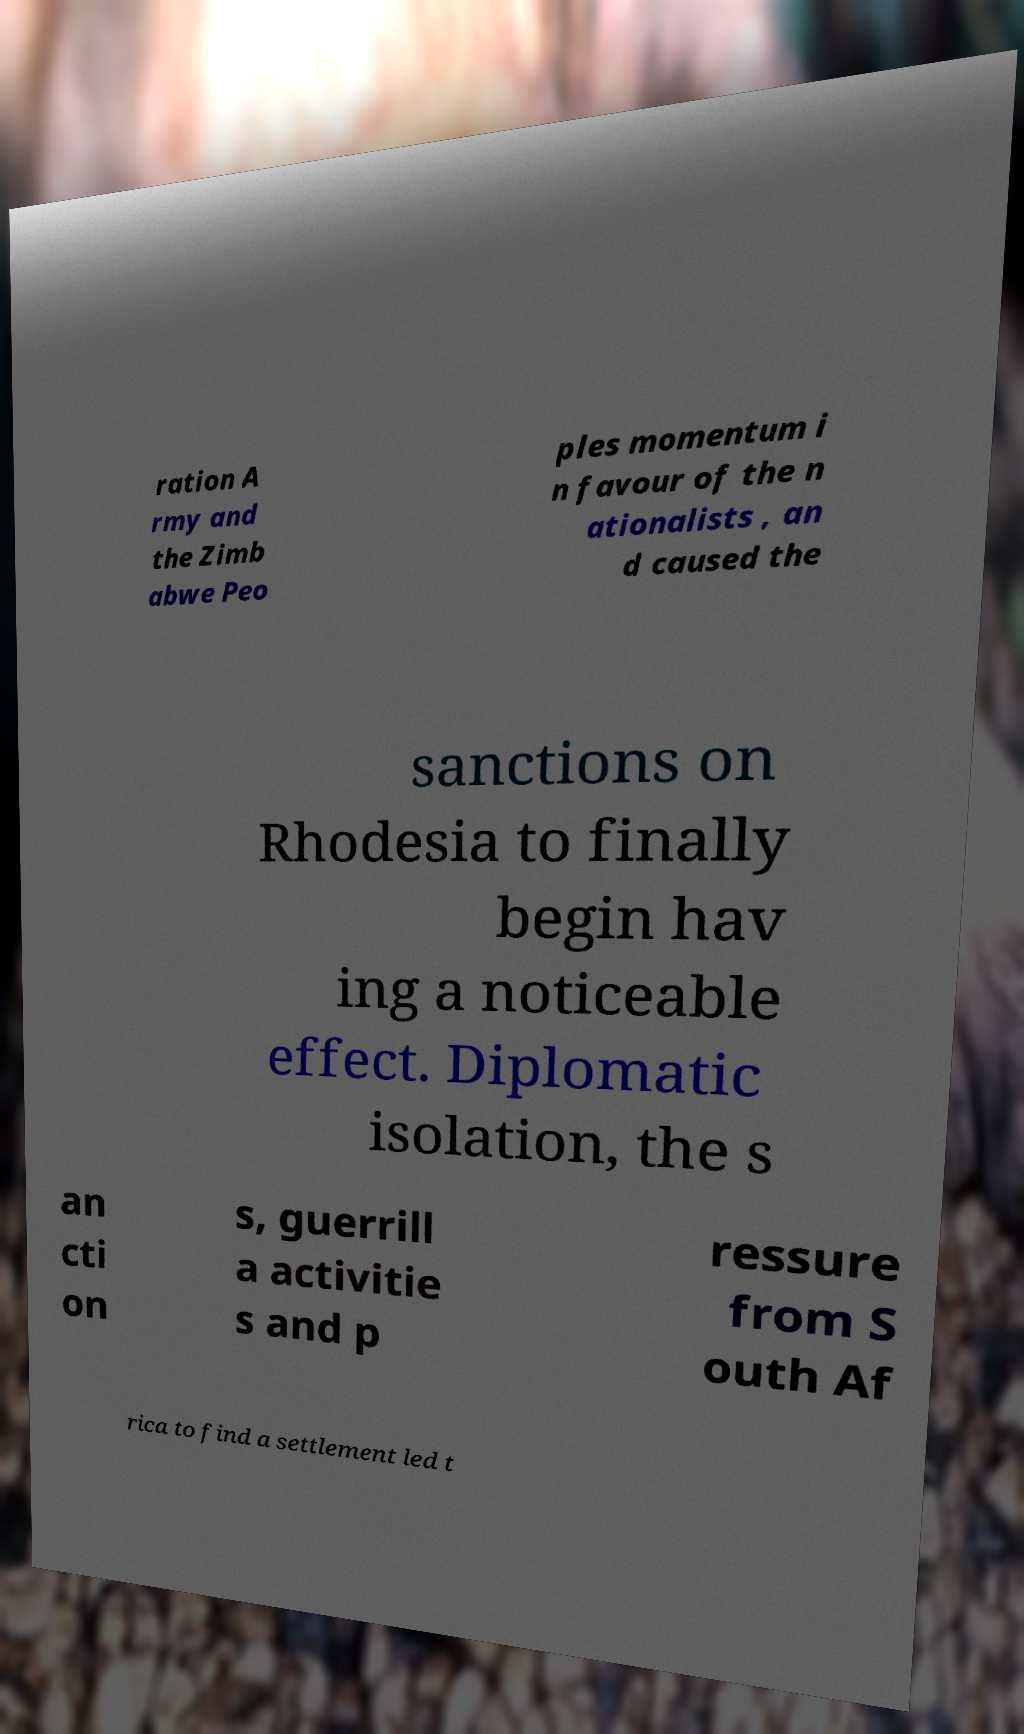I need the written content from this picture converted into text. Can you do that? ration A rmy and the Zimb abwe Peo ples momentum i n favour of the n ationalists , an d caused the sanctions on Rhodesia to finally begin hav ing a noticeable effect. Diplomatic isolation, the s an cti on s, guerrill a activitie s and p ressure from S outh Af rica to find a settlement led t 